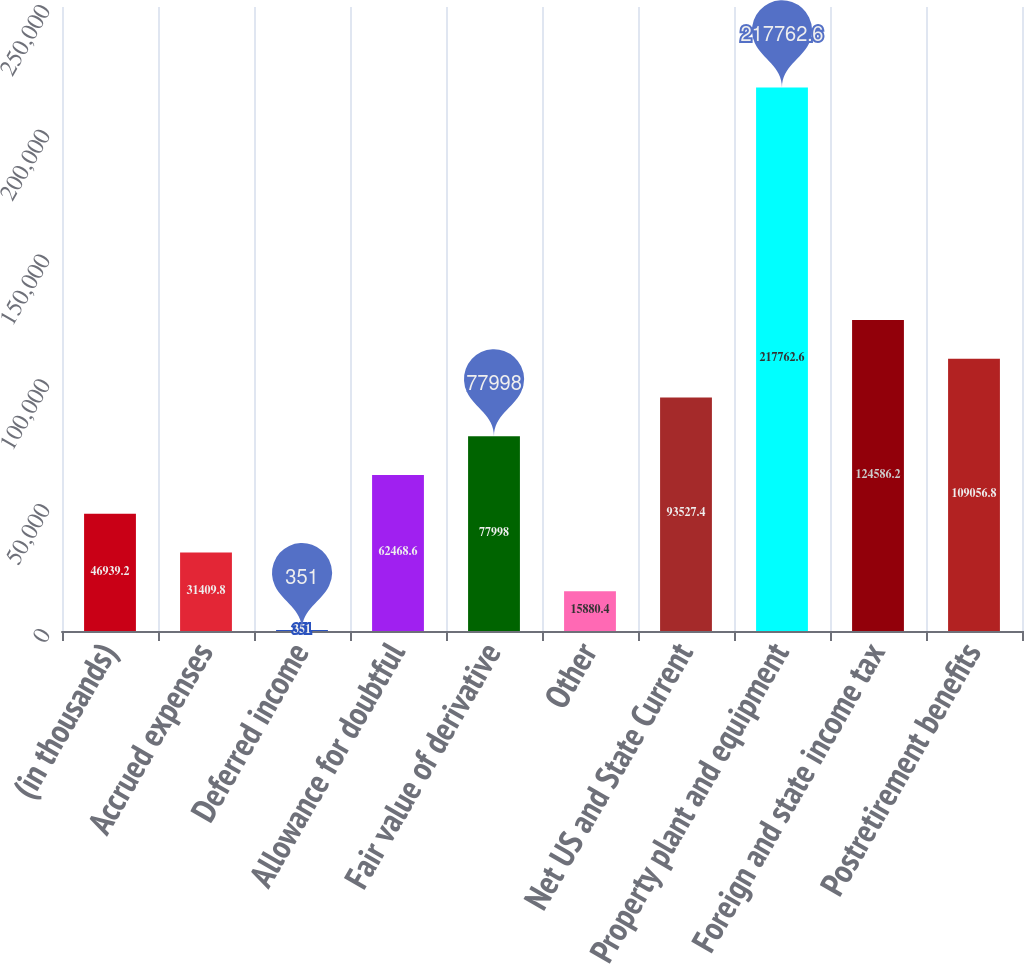Convert chart to OTSL. <chart><loc_0><loc_0><loc_500><loc_500><bar_chart><fcel>(in thousands)<fcel>Accrued expenses<fcel>Deferred income<fcel>Allowance for doubtful<fcel>Fair value of derivative<fcel>Other<fcel>Net US and State Current<fcel>Property plant and equipment<fcel>Foreign and state income tax<fcel>Postretirement benefits<nl><fcel>46939.2<fcel>31409.8<fcel>351<fcel>62468.6<fcel>77998<fcel>15880.4<fcel>93527.4<fcel>217763<fcel>124586<fcel>109057<nl></chart> 